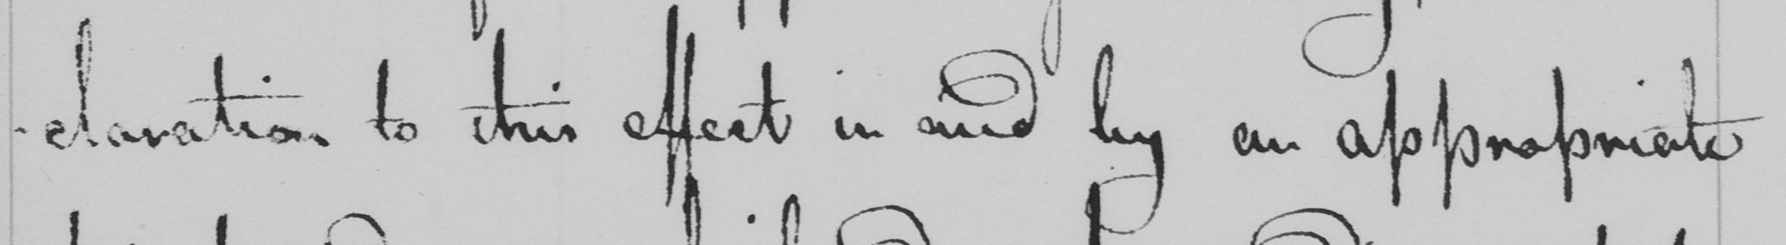Please provide the text content of this handwritten line. -claration to this effect in and by an appropriate 